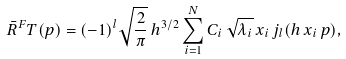Convert formula to latex. <formula><loc_0><loc_0><loc_500><loc_500>\bar { R } ^ { F } T ( p ) = ( - 1 ) ^ { l } \sqrt { \frac { 2 } { \pi } } \, h ^ { 3 / 2 } \sum _ { i = 1 } ^ { N } C _ { i } \, \sqrt { \lambda _ { i } } \, x _ { i } \, j _ { l } ( h \, x _ { i } \, p ) ,</formula> 